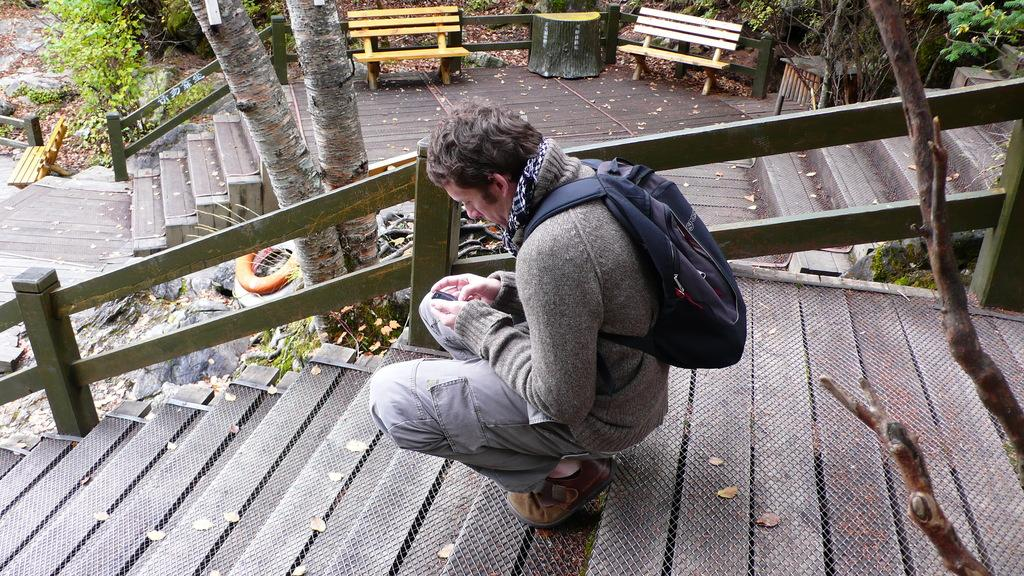What position is the man in the image? The man is sitting in a squat position. What is the man holding in the image? The man is holding a mobile. What is the man carrying in the image? The man is carrying a bag. What architectural feature is visible in the image? There are steps visible in the image. What natural elements are visible in the image? There are branches and a tree visible in the image. What is visible in the background of the image? There are branches, a tree, and plants visible in the background of the image. What type of lunch is the man eating in the image? There is no lunch visible in the image; the man is holding a mobile and carrying a bag. What sink is visible in the image? There is no sink present in the image. 